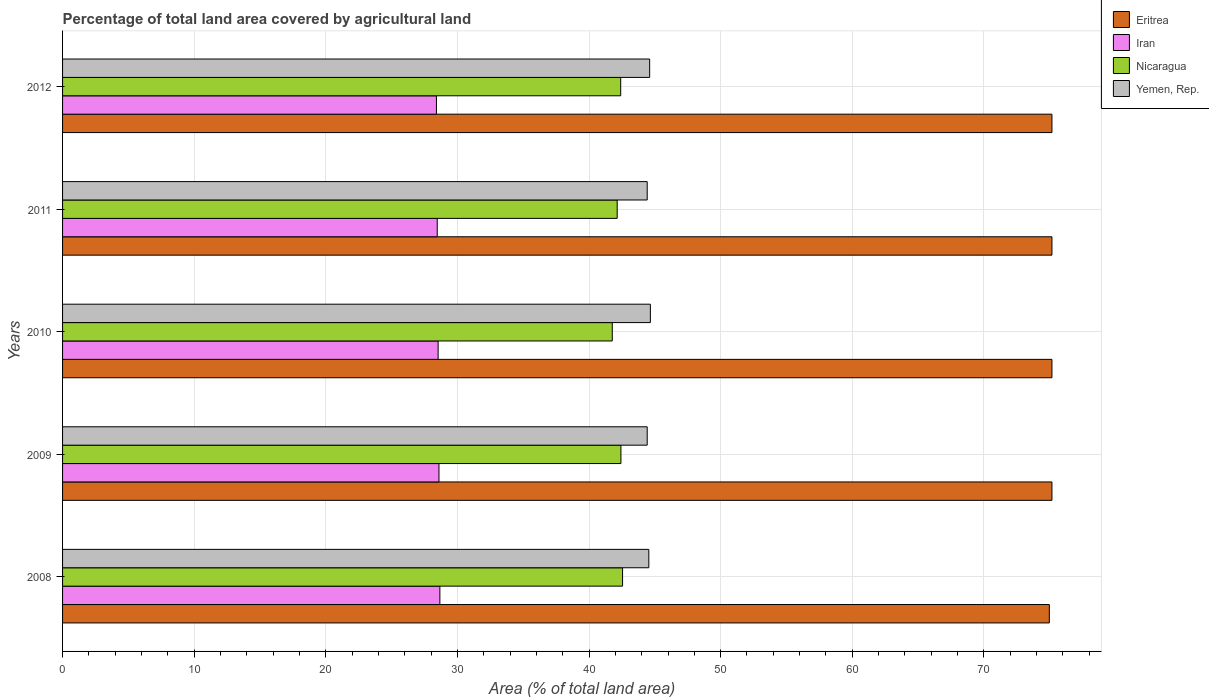Are the number of bars per tick equal to the number of legend labels?
Ensure brevity in your answer.  Yes. Are the number of bars on each tick of the Y-axis equal?
Your answer should be very brief. Yes. How many bars are there on the 4th tick from the top?
Ensure brevity in your answer.  4. How many bars are there on the 4th tick from the bottom?
Offer a terse response. 4. What is the label of the 3rd group of bars from the top?
Offer a very short reply. 2010. What is the percentage of agricultural land in Nicaragua in 2011?
Provide a short and direct response. 42.14. Across all years, what is the maximum percentage of agricultural land in Yemen, Rep.?
Offer a terse response. 44.66. Across all years, what is the minimum percentage of agricultural land in Yemen, Rep.?
Keep it short and to the point. 44.42. In which year was the percentage of agricultural land in Yemen, Rep. maximum?
Make the answer very short. 2010. What is the total percentage of agricultural land in Iran in the graph?
Your response must be concise. 142.67. What is the difference between the percentage of agricultural land in Yemen, Rep. in 2008 and that in 2012?
Your answer should be compact. -0.06. What is the difference between the percentage of agricultural land in Iran in 2011 and the percentage of agricultural land in Nicaragua in 2008?
Offer a very short reply. -14.08. What is the average percentage of agricultural land in Eritrea per year?
Make the answer very short. 75.13. In the year 2008, what is the difference between the percentage of agricultural land in Yemen, Rep. and percentage of agricultural land in Iran?
Keep it short and to the point. 15.88. In how many years, is the percentage of agricultural land in Nicaragua greater than 30 %?
Your response must be concise. 5. What is the ratio of the percentage of agricultural land in Iran in 2010 to that in 2012?
Provide a short and direct response. 1. Is the percentage of agricultural land in Iran in 2009 less than that in 2010?
Your answer should be very brief. No. What is the difference between the highest and the second highest percentage of agricultural land in Eritrea?
Your answer should be compact. 0. What is the difference between the highest and the lowest percentage of agricultural land in Yemen, Rep.?
Keep it short and to the point. 0.24. Is the sum of the percentage of agricultural land in Iran in 2009 and 2012 greater than the maximum percentage of agricultural land in Nicaragua across all years?
Provide a short and direct response. Yes. Is it the case that in every year, the sum of the percentage of agricultural land in Nicaragua and percentage of agricultural land in Eritrea is greater than the sum of percentage of agricultural land in Iran and percentage of agricultural land in Yemen, Rep.?
Your response must be concise. Yes. What does the 2nd bar from the top in 2011 represents?
Keep it short and to the point. Nicaragua. What does the 3rd bar from the bottom in 2011 represents?
Offer a terse response. Nicaragua. How many bars are there?
Your answer should be very brief. 20. How many years are there in the graph?
Offer a terse response. 5. What is the difference between two consecutive major ticks on the X-axis?
Your answer should be very brief. 10. Are the values on the major ticks of X-axis written in scientific E-notation?
Ensure brevity in your answer.  No. Does the graph contain grids?
Ensure brevity in your answer.  Yes. Where does the legend appear in the graph?
Your response must be concise. Top right. How many legend labels are there?
Keep it short and to the point. 4. What is the title of the graph?
Your response must be concise. Percentage of total land area covered by agricultural land. What is the label or title of the X-axis?
Offer a terse response. Area (% of total land area). What is the label or title of the Y-axis?
Provide a succinct answer. Years. What is the Area (% of total land area) of Eritrea in 2008?
Offer a terse response. 74.97. What is the Area (% of total land area) of Iran in 2008?
Offer a terse response. 28.67. What is the Area (% of total land area) of Nicaragua in 2008?
Ensure brevity in your answer.  42.55. What is the Area (% of total land area) in Yemen, Rep. in 2008?
Your response must be concise. 44.54. What is the Area (% of total land area) of Eritrea in 2009?
Your answer should be compact. 75.17. What is the Area (% of total land area) in Iran in 2009?
Your answer should be very brief. 28.6. What is the Area (% of total land area) of Nicaragua in 2009?
Give a very brief answer. 42.42. What is the Area (% of total land area) of Yemen, Rep. in 2009?
Your response must be concise. 44.42. What is the Area (% of total land area) of Eritrea in 2010?
Give a very brief answer. 75.17. What is the Area (% of total land area) of Iran in 2010?
Make the answer very short. 28.53. What is the Area (% of total land area) in Nicaragua in 2010?
Your answer should be very brief. 41.76. What is the Area (% of total land area) of Yemen, Rep. in 2010?
Offer a very short reply. 44.66. What is the Area (% of total land area) in Eritrea in 2011?
Make the answer very short. 75.17. What is the Area (% of total land area) of Iran in 2011?
Keep it short and to the point. 28.47. What is the Area (% of total land area) of Nicaragua in 2011?
Your answer should be very brief. 42.14. What is the Area (% of total land area) of Yemen, Rep. in 2011?
Give a very brief answer. 44.42. What is the Area (% of total land area) of Eritrea in 2012?
Ensure brevity in your answer.  75.17. What is the Area (% of total land area) in Iran in 2012?
Offer a terse response. 28.41. What is the Area (% of total land area) of Nicaragua in 2012?
Offer a terse response. 42.4. What is the Area (% of total land area) of Yemen, Rep. in 2012?
Keep it short and to the point. 44.6. Across all years, what is the maximum Area (% of total land area) of Eritrea?
Provide a short and direct response. 75.17. Across all years, what is the maximum Area (% of total land area) of Iran?
Your answer should be compact. 28.67. Across all years, what is the maximum Area (% of total land area) in Nicaragua?
Keep it short and to the point. 42.55. Across all years, what is the maximum Area (% of total land area) of Yemen, Rep.?
Make the answer very short. 44.66. Across all years, what is the minimum Area (% of total land area) in Eritrea?
Offer a terse response. 74.97. Across all years, what is the minimum Area (% of total land area) of Iran?
Ensure brevity in your answer.  28.41. Across all years, what is the minimum Area (% of total land area) in Nicaragua?
Provide a succinct answer. 41.76. Across all years, what is the minimum Area (% of total land area) in Yemen, Rep.?
Provide a short and direct response. 44.42. What is the total Area (% of total land area) of Eritrea in the graph?
Your answer should be very brief. 375.64. What is the total Area (% of total land area) of Iran in the graph?
Offer a terse response. 142.67. What is the total Area (% of total land area) in Nicaragua in the graph?
Ensure brevity in your answer.  211.28. What is the total Area (% of total land area) in Yemen, Rep. in the graph?
Provide a short and direct response. 222.65. What is the difference between the Area (% of total land area) of Eritrea in 2008 and that in 2009?
Your answer should be very brief. -0.2. What is the difference between the Area (% of total land area) in Iran in 2008 and that in 2009?
Give a very brief answer. 0.07. What is the difference between the Area (% of total land area) in Nicaragua in 2008 and that in 2009?
Provide a succinct answer. 0.12. What is the difference between the Area (% of total land area) in Yemen, Rep. in 2008 and that in 2009?
Your answer should be compact. 0.12. What is the difference between the Area (% of total land area) in Eritrea in 2008 and that in 2010?
Keep it short and to the point. -0.2. What is the difference between the Area (% of total land area) of Iran in 2008 and that in 2010?
Provide a short and direct response. 0.13. What is the difference between the Area (% of total land area) of Nicaragua in 2008 and that in 2010?
Offer a very short reply. 0.78. What is the difference between the Area (% of total land area) of Yemen, Rep. in 2008 and that in 2010?
Offer a very short reply. -0.12. What is the difference between the Area (% of total land area) in Eritrea in 2008 and that in 2011?
Offer a very short reply. -0.2. What is the difference between the Area (% of total land area) in Iran in 2008 and that in 2011?
Provide a short and direct response. 0.2. What is the difference between the Area (% of total land area) in Nicaragua in 2008 and that in 2011?
Offer a terse response. 0.41. What is the difference between the Area (% of total land area) of Yemen, Rep. in 2008 and that in 2011?
Provide a succinct answer. 0.12. What is the difference between the Area (% of total land area) in Eritrea in 2008 and that in 2012?
Provide a short and direct response. -0.2. What is the difference between the Area (% of total land area) in Iran in 2008 and that in 2012?
Make the answer very short. 0.26. What is the difference between the Area (% of total land area) in Nicaragua in 2008 and that in 2012?
Your answer should be compact. 0.14. What is the difference between the Area (% of total land area) of Yemen, Rep. in 2008 and that in 2012?
Your answer should be compact. -0.06. What is the difference between the Area (% of total land area) of Eritrea in 2009 and that in 2010?
Provide a succinct answer. 0. What is the difference between the Area (% of total land area) in Iran in 2009 and that in 2010?
Give a very brief answer. 0.06. What is the difference between the Area (% of total land area) in Nicaragua in 2009 and that in 2010?
Your response must be concise. 0.66. What is the difference between the Area (% of total land area) in Yemen, Rep. in 2009 and that in 2010?
Give a very brief answer. -0.24. What is the difference between the Area (% of total land area) of Eritrea in 2009 and that in 2011?
Make the answer very short. 0. What is the difference between the Area (% of total land area) in Iran in 2009 and that in 2011?
Ensure brevity in your answer.  0.13. What is the difference between the Area (% of total land area) of Nicaragua in 2009 and that in 2011?
Keep it short and to the point. 0.28. What is the difference between the Area (% of total land area) of Yemen, Rep. in 2009 and that in 2011?
Keep it short and to the point. 0. What is the difference between the Area (% of total land area) of Iran in 2009 and that in 2012?
Give a very brief answer. 0.19. What is the difference between the Area (% of total land area) in Nicaragua in 2009 and that in 2012?
Offer a very short reply. 0.02. What is the difference between the Area (% of total land area) in Yemen, Rep. in 2009 and that in 2012?
Your answer should be very brief. -0.19. What is the difference between the Area (% of total land area) of Eritrea in 2010 and that in 2011?
Offer a terse response. 0. What is the difference between the Area (% of total land area) in Iran in 2010 and that in 2011?
Your response must be concise. 0.07. What is the difference between the Area (% of total land area) in Nicaragua in 2010 and that in 2011?
Make the answer very short. -0.37. What is the difference between the Area (% of total land area) of Yemen, Rep. in 2010 and that in 2011?
Offer a very short reply. 0.24. What is the difference between the Area (% of total land area) of Iran in 2010 and that in 2012?
Make the answer very short. 0.13. What is the difference between the Area (% of total land area) in Nicaragua in 2010 and that in 2012?
Give a very brief answer. -0.64. What is the difference between the Area (% of total land area) in Yemen, Rep. in 2010 and that in 2012?
Your answer should be compact. 0.05. What is the difference between the Area (% of total land area) of Eritrea in 2011 and that in 2012?
Provide a short and direct response. 0. What is the difference between the Area (% of total land area) of Iran in 2011 and that in 2012?
Give a very brief answer. 0.06. What is the difference between the Area (% of total land area) of Nicaragua in 2011 and that in 2012?
Your answer should be very brief. -0.27. What is the difference between the Area (% of total land area) of Yemen, Rep. in 2011 and that in 2012?
Offer a terse response. -0.19. What is the difference between the Area (% of total land area) in Eritrea in 2008 and the Area (% of total land area) in Iran in 2009?
Keep it short and to the point. 46.37. What is the difference between the Area (% of total land area) in Eritrea in 2008 and the Area (% of total land area) in Nicaragua in 2009?
Your response must be concise. 32.55. What is the difference between the Area (% of total land area) in Eritrea in 2008 and the Area (% of total land area) in Yemen, Rep. in 2009?
Your answer should be compact. 30.55. What is the difference between the Area (% of total land area) in Iran in 2008 and the Area (% of total land area) in Nicaragua in 2009?
Ensure brevity in your answer.  -13.75. What is the difference between the Area (% of total land area) in Iran in 2008 and the Area (% of total land area) in Yemen, Rep. in 2009?
Your answer should be compact. -15.75. What is the difference between the Area (% of total land area) of Nicaragua in 2008 and the Area (% of total land area) of Yemen, Rep. in 2009?
Provide a short and direct response. -1.87. What is the difference between the Area (% of total land area) of Eritrea in 2008 and the Area (% of total land area) of Iran in 2010?
Provide a succinct answer. 46.44. What is the difference between the Area (% of total land area) in Eritrea in 2008 and the Area (% of total land area) in Nicaragua in 2010?
Offer a very short reply. 33.21. What is the difference between the Area (% of total land area) in Eritrea in 2008 and the Area (% of total land area) in Yemen, Rep. in 2010?
Provide a succinct answer. 30.31. What is the difference between the Area (% of total land area) in Iran in 2008 and the Area (% of total land area) in Nicaragua in 2010?
Your answer should be compact. -13.1. What is the difference between the Area (% of total land area) in Iran in 2008 and the Area (% of total land area) in Yemen, Rep. in 2010?
Provide a succinct answer. -15.99. What is the difference between the Area (% of total land area) of Nicaragua in 2008 and the Area (% of total land area) of Yemen, Rep. in 2010?
Make the answer very short. -2.11. What is the difference between the Area (% of total land area) of Eritrea in 2008 and the Area (% of total land area) of Iran in 2011?
Provide a short and direct response. 46.5. What is the difference between the Area (% of total land area) in Eritrea in 2008 and the Area (% of total land area) in Nicaragua in 2011?
Keep it short and to the point. 32.83. What is the difference between the Area (% of total land area) in Eritrea in 2008 and the Area (% of total land area) in Yemen, Rep. in 2011?
Make the answer very short. 30.55. What is the difference between the Area (% of total land area) of Iran in 2008 and the Area (% of total land area) of Nicaragua in 2011?
Your answer should be compact. -13.47. What is the difference between the Area (% of total land area) in Iran in 2008 and the Area (% of total land area) in Yemen, Rep. in 2011?
Offer a very short reply. -15.75. What is the difference between the Area (% of total land area) of Nicaragua in 2008 and the Area (% of total land area) of Yemen, Rep. in 2011?
Keep it short and to the point. -1.87. What is the difference between the Area (% of total land area) of Eritrea in 2008 and the Area (% of total land area) of Iran in 2012?
Offer a terse response. 46.56. What is the difference between the Area (% of total land area) in Eritrea in 2008 and the Area (% of total land area) in Nicaragua in 2012?
Ensure brevity in your answer.  32.57. What is the difference between the Area (% of total land area) in Eritrea in 2008 and the Area (% of total land area) in Yemen, Rep. in 2012?
Make the answer very short. 30.37. What is the difference between the Area (% of total land area) of Iran in 2008 and the Area (% of total land area) of Nicaragua in 2012?
Make the answer very short. -13.74. What is the difference between the Area (% of total land area) of Iran in 2008 and the Area (% of total land area) of Yemen, Rep. in 2012?
Provide a short and direct response. -15.94. What is the difference between the Area (% of total land area) in Nicaragua in 2008 and the Area (% of total land area) in Yemen, Rep. in 2012?
Your answer should be very brief. -2.06. What is the difference between the Area (% of total land area) of Eritrea in 2009 and the Area (% of total land area) of Iran in 2010?
Provide a succinct answer. 46.63. What is the difference between the Area (% of total land area) in Eritrea in 2009 and the Area (% of total land area) in Nicaragua in 2010?
Your answer should be very brief. 33.4. What is the difference between the Area (% of total land area) of Eritrea in 2009 and the Area (% of total land area) of Yemen, Rep. in 2010?
Offer a terse response. 30.51. What is the difference between the Area (% of total land area) in Iran in 2009 and the Area (% of total land area) in Nicaragua in 2010?
Ensure brevity in your answer.  -13.17. What is the difference between the Area (% of total land area) of Iran in 2009 and the Area (% of total land area) of Yemen, Rep. in 2010?
Keep it short and to the point. -16.06. What is the difference between the Area (% of total land area) of Nicaragua in 2009 and the Area (% of total land area) of Yemen, Rep. in 2010?
Ensure brevity in your answer.  -2.24. What is the difference between the Area (% of total land area) of Eritrea in 2009 and the Area (% of total land area) of Iran in 2011?
Give a very brief answer. 46.7. What is the difference between the Area (% of total land area) in Eritrea in 2009 and the Area (% of total land area) in Nicaragua in 2011?
Your answer should be very brief. 33.03. What is the difference between the Area (% of total land area) of Eritrea in 2009 and the Area (% of total land area) of Yemen, Rep. in 2011?
Give a very brief answer. 30.75. What is the difference between the Area (% of total land area) of Iran in 2009 and the Area (% of total land area) of Nicaragua in 2011?
Provide a short and direct response. -13.54. What is the difference between the Area (% of total land area) of Iran in 2009 and the Area (% of total land area) of Yemen, Rep. in 2011?
Your response must be concise. -15.82. What is the difference between the Area (% of total land area) of Nicaragua in 2009 and the Area (% of total land area) of Yemen, Rep. in 2011?
Your answer should be compact. -2. What is the difference between the Area (% of total land area) of Eritrea in 2009 and the Area (% of total land area) of Iran in 2012?
Make the answer very short. 46.76. What is the difference between the Area (% of total land area) of Eritrea in 2009 and the Area (% of total land area) of Nicaragua in 2012?
Your response must be concise. 32.76. What is the difference between the Area (% of total land area) in Eritrea in 2009 and the Area (% of total land area) in Yemen, Rep. in 2012?
Make the answer very short. 30.56. What is the difference between the Area (% of total land area) in Iran in 2009 and the Area (% of total land area) in Nicaragua in 2012?
Your response must be concise. -13.81. What is the difference between the Area (% of total land area) of Iran in 2009 and the Area (% of total land area) of Yemen, Rep. in 2012?
Ensure brevity in your answer.  -16.01. What is the difference between the Area (% of total land area) of Nicaragua in 2009 and the Area (% of total land area) of Yemen, Rep. in 2012?
Your answer should be very brief. -2.18. What is the difference between the Area (% of total land area) in Eritrea in 2010 and the Area (% of total land area) in Iran in 2011?
Provide a short and direct response. 46.7. What is the difference between the Area (% of total land area) in Eritrea in 2010 and the Area (% of total land area) in Nicaragua in 2011?
Keep it short and to the point. 33.03. What is the difference between the Area (% of total land area) of Eritrea in 2010 and the Area (% of total land area) of Yemen, Rep. in 2011?
Offer a terse response. 30.75. What is the difference between the Area (% of total land area) of Iran in 2010 and the Area (% of total land area) of Nicaragua in 2011?
Make the answer very short. -13.6. What is the difference between the Area (% of total land area) in Iran in 2010 and the Area (% of total land area) in Yemen, Rep. in 2011?
Offer a very short reply. -15.89. What is the difference between the Area (% of total land area) in Nicaragua in 2010 and the Area (% of total land area) in Yemen, Rep. in 2011?
Your answer should be very brief. -2.65. What is the difference between the Area (% of total land area) of Eritrea in 2010 and the Area (% of total land area) of Iran in 2012?
Make the answer very short. 46.76. What is the difference between the Area (% of total land area) in Eritrea in 2010 and the Area (% of total land area) in Nicaragua in 2012?
Your response must be concise. 32.76. What is the difference between the Area (% of total land area) of Eritrea in 2010 and the Area (% of total land area) of Yemen, Rep. in 2012?
Ensure brevity in your answer.  30.56. What is the difference between the Area (% of total land area) of Iran in 2010 and the Area (% of total land area) of Nicaragua in 2012?
Provide a short and direct response. -13.87. What is the difference between the Area (% of total land area) of Iran in 2010 and the Area (% of total land area) of Yemen, Rep. in 2012?
Your answer should be very brief. -16.07. What is the difference between the Area (% of total land area) in Nicaragua in 2010 and the Area (% of total land area) in Yemen, Rep. in 2012?
Offer a very short reply. -2.84. What is the difference between the Area (% of total land area) of Eritrea in 2011 and the Area (% of total land area) of Iran in 2012?
Offer a terse response. 46.76. What is the difference between the Area (% of total land area) of Eritrea in 2011 and the Area (% of total land area) of Nicaragua in 2012?
Keep it short and to the point. 32.76. What is the difference between the Area (% of total land area) of Eritrea in 2011 and the Area (% of total land area) of Yemen, Rep. in 2012?
Give a very brief answer. 30.56. What is the difference between the Area (% of total land area) in Iran in 2011 and the Area (% of total land area) in Nicaragua in 2012?
Provide a short and direct response. -13.94. What is the difference between the Area (% of total land area) of Iran in 2011 and the Area (% of total land area) of Yemen, Rep. in 2012?
Your answer should be compact. -16.14. What is the difference between the Area (% of total land area) of Nicaragua in 2011 and the Area (% of total land area) of Yemen, Rep. in 2012?
Your response must be concise. -2.47. What is the average Area (% of total land area) in Eritrea per year?
Offer a very short reply. 75.13. What is the average Area (% of total land area) of Iran per year?
Keep it short and to the point. 28.53. What is the average Area (% of total land area) in Nicaragua per year?
Provide a short and direct response. 42.26. What is the average Area (% of total land area) in Yemen, Rep. per year?
Make the answer very short. 44.53. In the year 2008, what is the difference between the Area (% of total land area) in Eritrea and Area (% of total land area) in Iran?
Your response must be concise. 46.3. In the year 2008, what is the difference between the Area (% of total land area) in Eritrea and Area (% of total land area) in Nicaragua?
Give a very brief answer. 32.42. In the year 2008, what is the difference between the Area (% of total land area) of Eritrea and Area (% of total land area) of Yemen, Rep.?
Your answer should be very brief. 30.43. In the year 2008, what is the difference between the Area (% of total land area) in Iran and Area (% of total land area) in Nicaragua?
Offer a very short reply. -13.88. In the year 2008, what is the difference between the Area (% of total land area) in Iran and Area (% of total land area) in Yemen, Rep.?
Give a very brief answer. -15.88. In the year 2008, what is the difference between the Area (% of total land area) in Nicaragua and Area (% of total land area) in Yemen, Rep.?
Provide a short and direct response. -2. In the year 2009, what is the difference between the Area (% of total land area) of Eritrea and Area (% of total land area) of Iran?
Ensure brevity in your answer.  46.57. In the year 2009, what is the difference between the Area (% of total land area) of Eritrea and Area (% of total land area) of Nicaragua?
Give a very brief answer. 32.75. In the year 2009, what is the difference between the Area (% of total land area) of Eritrea and Area (% of total land area) of Yemen, Rep.?
Offer a terse response. 30.75. In the year 2009, what is the difference between the Area (% of total land area) in Iran and Area (% of total land area) in Nicaragua?
Ensure brevity in your answer.  -13.82. In the year 2009, what is the difference between the Area (% of total land area) in Iran and Area (% of total land area) in Yemen, Rep.?
Make the answer very short. -15.82. In the year 2009, what is the difference between the Area (% of total land area) in Nicaragua and Area (% of total land area) in Yemen, Rep.?
Provide a short and direct response. -2. In the year 2010, what is the difference between the Area (% of total land area) in Eritrea and Area (% of total land area) in Iran?
Your answer should be very brief. 46.63. In the year 2010, what is the difference between the Area (% of total land area) in Eritrea and Area (% of total land area) in Nicaragua?
Provide a short and direct response. 33.4. In the year 2010, what is the difference between the Area (% of total land area) in Eritrea and Area (% of total land area) in Yemen, Rep.?
Provide a succinct answer. 30.51. In the year 2010, what is the difference between the Area (% of total land area) in Iran and Area (% of total land area) in Nicaragua?
Give a very brief answer. -13.23. In the year 2010, what is the difference between the Area (% of total land area) in Iran and Area (% of total land area) in Yemen, Rep.?
Ensure brevity in your answer.  -16.13. In the year 2010, what is the difference between the Area (% of total land area) of Nicaragua and Area (% of total land area) of Yemen, Rep.?
Your answer should be compact. -2.89. In the year 2011, what is the difference between the Area (% of total land area) in Eritrea and Area (% of total land area) in Iran?
Offer a very short reply. 46.7. In the year 2011, what is the difference between the Area (% of total land area) in Eritrea and Area (% of total land area) in Nicaragua?
Offer a terse response. 33.03. In the year 2011, what is the difference between the Area (% of total land area) in Eritrea and Area (% of total land area) in Yemen, Rep.?
Your response must be concise. 30.75. In the year 2011, what is the difference between the Area (% of total land area) in Iran and Area (% of total land area) in Nicaragua?
Ensure brevity in your answer.  -13.67. In the year 2011, what is the difference between the Area (% of total land area) of Iran and Area (% of total land area) of Yemen, Rep.?
Provide a succinct answer. -15.95. In the year 2011, what is the difference between the Area (% of total land area) of Nicaragua and Area (% of total land area) of Yemen, Rep.?
Ensure brevity in your answer.  -2.28. In the year 2012, what is the difference between the Area (% of total land area) of Eritrea and Area (% of total land area) of Iran?
Offer a very short reply. 46.76. In the year 2012, what is the difference between the Area (% of total land area) of Eritrea and Area (% of total land area) of Nicaragua?
Keep it short and to the point. 32.76. In the year 2012, what is the difference between the Area (% of total land area) in Eritrea and Area (% of total land area) in Yemen, Rep.?
Provide a short and direct response. 30.56. In the year 2012, what is the difference between the Area (% of total land area) in Iran and Area (% of total land area) in Nicaragua?
Give a very brief answer. -14. In the year 2012, what is the difference between the Area (% of total land area) in Iran and Area (% of total land area) in Yemen, Rep.?
Ensure brevity in your answer.  -16.2. In the year 2012, what is the difference between the Area (% of total land area) of Nicaragua and Area (% of total land area) of Yemen, Rep.?
Ensure brevity in your answer.  -2.2. What is the ratio of the Area (% of total land area) in Eritrea in 2008 to that in 2009?
Offer a very short reply. 1. What is the ratio of the Area (% of total land area) in Iran in 2008 to that in 2009?
Keep it short and to the point. 1. What is the ratio of the Area (% of total land area) of Yemen, Rep. in 2008 to that in 2009?
Ensure brevity in your answer.  1. What is the ratio of the Area (% of total land area) of Eritrea in 2008 to that in 2010?
Give a very brief answer. 1. What is the ratio of the Area (% of total land area) in Nicaragua in 2008 to that in 2010?
Give a very brief answer. 1.02. What is the ratio of the Area (% of total land area) of Yemen, Rep. in 2008 to that in 2010?
Your answer should be compact. 1. What is the ratio of the Area (% of total land area) of Iran in 2008 to that in 2011?
Your answer should be compact. 1.01. What is the ratio of the Area (% of total land area) of Nicaragua in 2008 to that in 2011?
Your answer should be very brief. 1.01. What is the ratio of the Area (% of total land area) of Eritrea in 2008 to that in 2012?
Ensure brevity in your answer.  1. What is the ratio of the Area (% of total land area) of Iran in 2008 to that in 2012?
Provide a short and direct response. 1.01. What is the ratio of the Area (% of total land area) of Nicaragua in 2008 to that in 2012?
Your answer should be very brief. 1. What is the ratio of the Area (% of total land area) in Yemen, Rep. in 2008 to that in 2012?
Offer a terse response. 1. What is the ratio of the Area (% of total land area) in Eritrea in 2009 to that in 2010?
Provide a short and direct response. 1. What is the ratio of the Area (% of total land area) of Iran in 2009 to that in 2010?
Your response must be concise. 1. What is the ratio of the Area (% of total land area) in Nicaragua in 2009 to that in 2010?
Your answer should be compact. 1.02. What is the ratio of the Area (% of total land area) in Eritrea in 2009 to that in 2011?
Your answer should be very brief. 1. What is the ratio of the Area (% of total land area) of Iran in 2009 to that in 2012?
Ensure brevity in your answer.  1.01. What is the ratio of the Area (% of total land area) of Yemen, Rep. in 2009 to that in 2012?
Your answer should be compact. 1. What is the ratio of the Area (% of total land area) in Eritrea in 2010 to that in 2011?
Offer a terse response. 1. What is the ratio of the Area (% of total land area) of Nicaragua in 2010 to that in 2011?
Offer a very short reply. 0.99. What is the ratio of the Area (% of total land area) in Yemen, Rep. in 2010 to that in 2011?
Your answer should be very brief. 1.01. What is the ratio of the Area (% of total land area) of Eritrea in 2010 to that in 2012?
Offer a very short reply. 1. What is the ratio of the Area (% of total land area) in Iran in 2010 to that in 2012?
Provide a succinct answer. 1. What is the ratio of the Area (% of total land area) of Nicaragua in 2010 to that in 2012?
Your response must be concise. 0.98. What is the ratio of the Area (% of total land area) in Eritrea in 2011 to that in 2012?
Offer a terse response. 1. What is the ratio of the Area (% of total land area) of Iran in 2011 to that in 2012?
Ensure brevity in your answer.  1. What is the difference between the highest and the second highest Area (% of total land area) of Eritrea?
Offer a terse response. 0. What is the difference between the highest and the second highest Area (% of total land area) of Iran?
Provide a short and direct response. 0.07. What is the difference between the highest and the second highest Area (% of total land area) of Nicaragua?
Provide a short and direct response. 0.12. What is the difference between the highest and the second highest Area (% of total land area) in Yemen, Rep.?
Ensure brevity in your answer.  0.05. What is the difference between the highest and the lowest Area (% of total land area) of Eritrea?
Offer a terse response. 0.2. What is the difference between the highest and the lowest Area (% of total land area) in Iran?
Keep it short and to the point. 0.26. What is the difference between the highest and the lowest Area (% of total land area) in Nicaragua?
Your response must be concise. 0.78. What is the difference between the highest and the lowest Area (% of total land area) in Yemen, Rep.?
Ensure brevity in your answer.  0.24. 